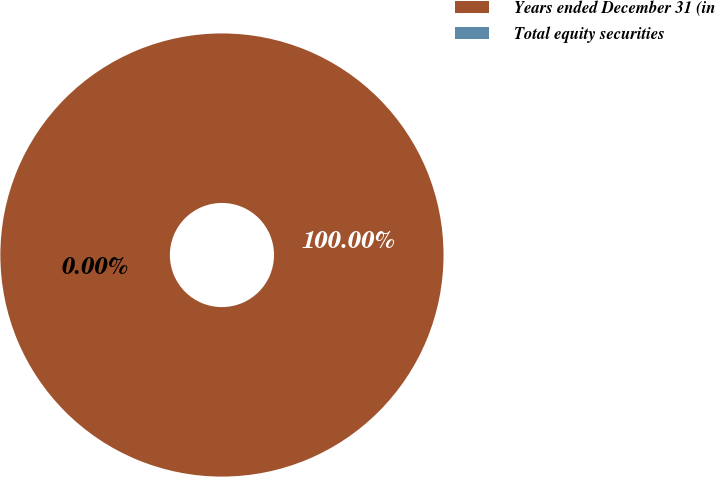Convert chart to OTSL. <chart><loc_0><loc_0><loc_500><loc_500><pie_chart><fcel>Years ended December 31 (in<fcel>Total equity securities<nl><fcel>100.0%<fcel>0.0%<nl></chart> 